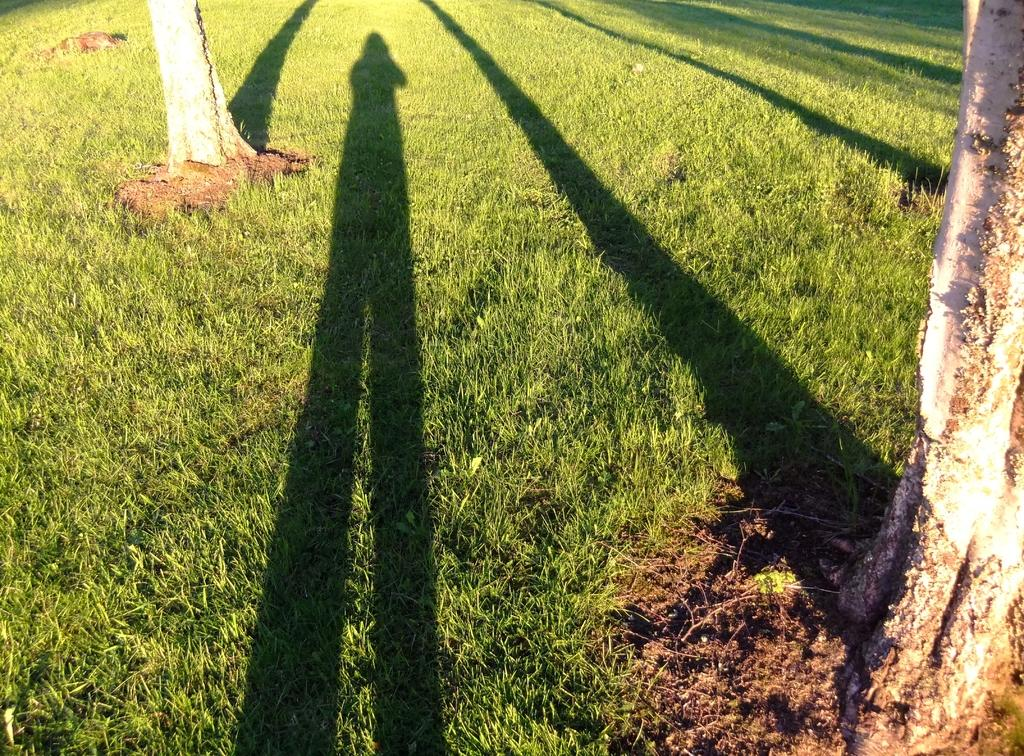What can be seen in the foreground of the picture? There are trees, red soil, grass, and shadows present in the foreground of the picture. What type of vegetation is visible in the foreground? Trees and grass are visible in the foreground of the picture. What is the color of the soil in the foreground? The soil in the foreground is red. Are there any shadows visible in the foreground? Yes, shadows are present in the foreground of the picture. What is visible at the top of the picture? There is grass at the top of the picture. Where is the book located in the picture? There is no book present in the picture. What type of vegetable is growing in the grass at the top of the picture? There is no vegetable visible in the picture; only grass is present at the top. 